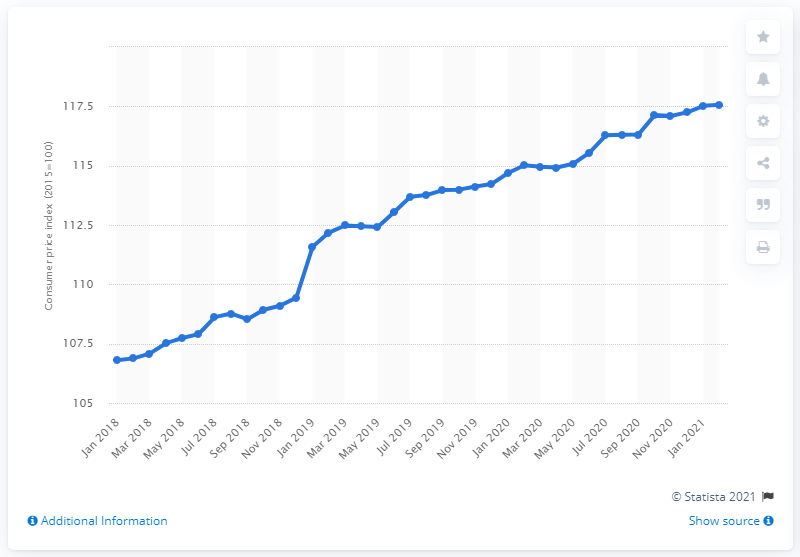Indicate a few pertinent items in this graphic. In January 2018, the index value of fast food was 106.8. 